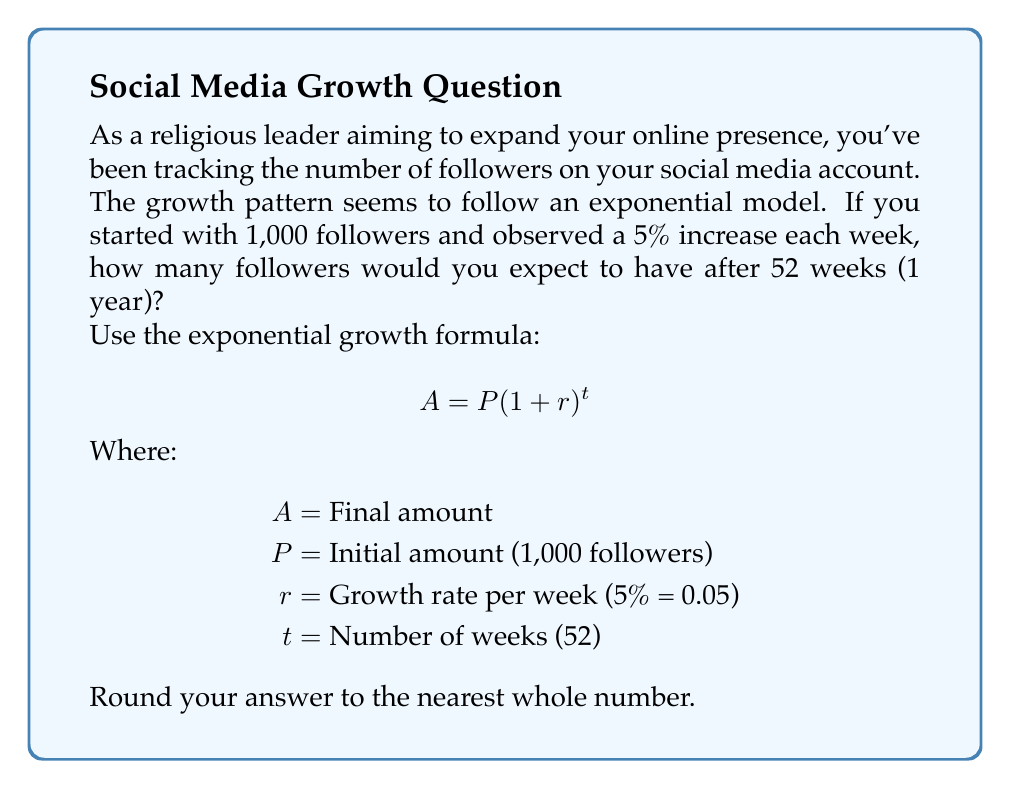Can you answer this question? Let's approach this step-by-step:

1) We're using the exponential growth formula: $A = P(1 + r)^t$

2) We know the following:
   $P = 1,000$ (initial followers)
   $r = 0.05$ (5% growth rate)
   $t = 52$ (weeks in a year)

3) Let's substitute these values into our formula:

   $A = 1,000(1 + 0.05)^{52}$

4) Simplify inside the parentheses:

   $A = 1,000(1.05)^{52}$

5) Now we need to calculate $(1.05)^{52}$. This is best done with a calculator:

   $(1.05)^{52} \approx 11.4674$

6) Multiply this by our initial amount:

   $A = 1,000 \times 11.4674 = 11,467.4$

7) Rounding to the nearest whole number:

   $A \approx 11,467$ followers

Therefore, after 52 weeks, you would expect to have approximately 11,467 followers.
Answer: 11,467 followers 